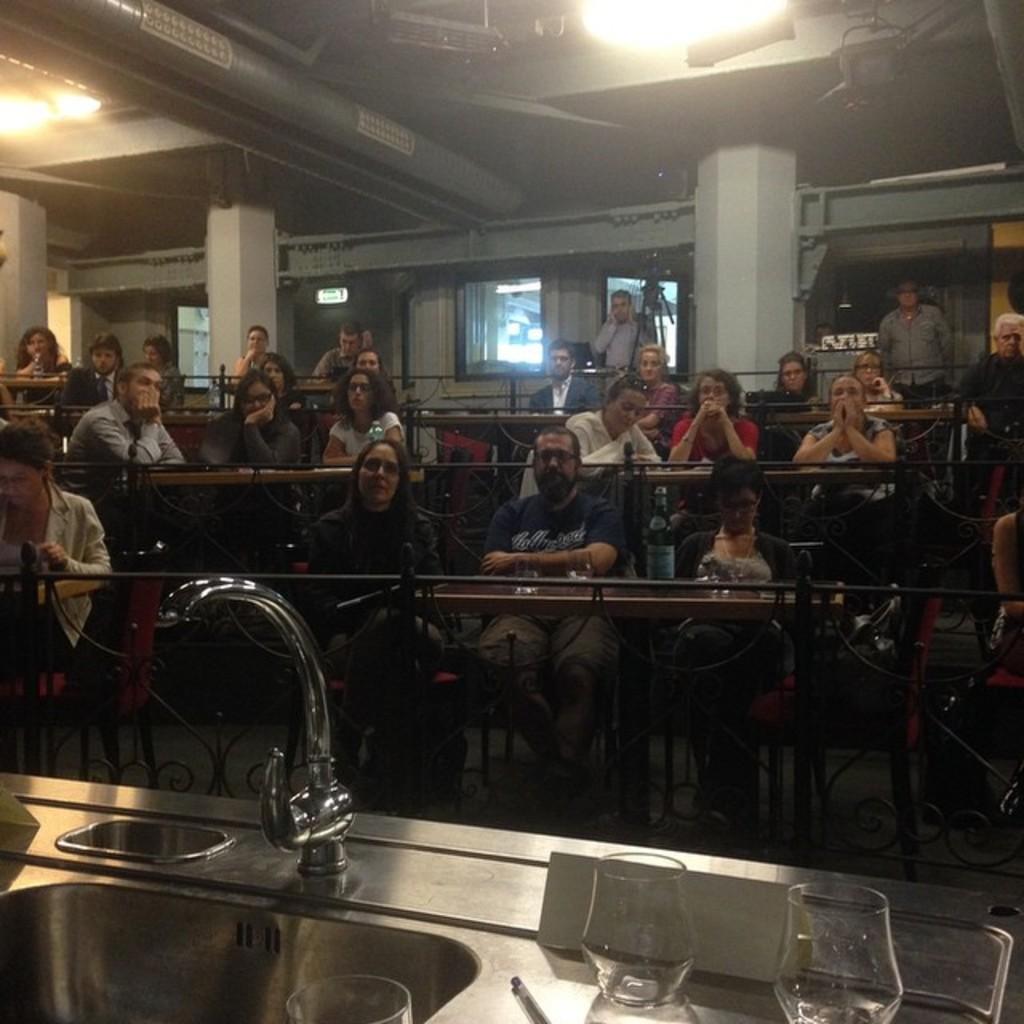Can you describe this image briefly? In this image there are group of persons sitting on the chairs and at the foreground of the image there is a tap and glasses. 